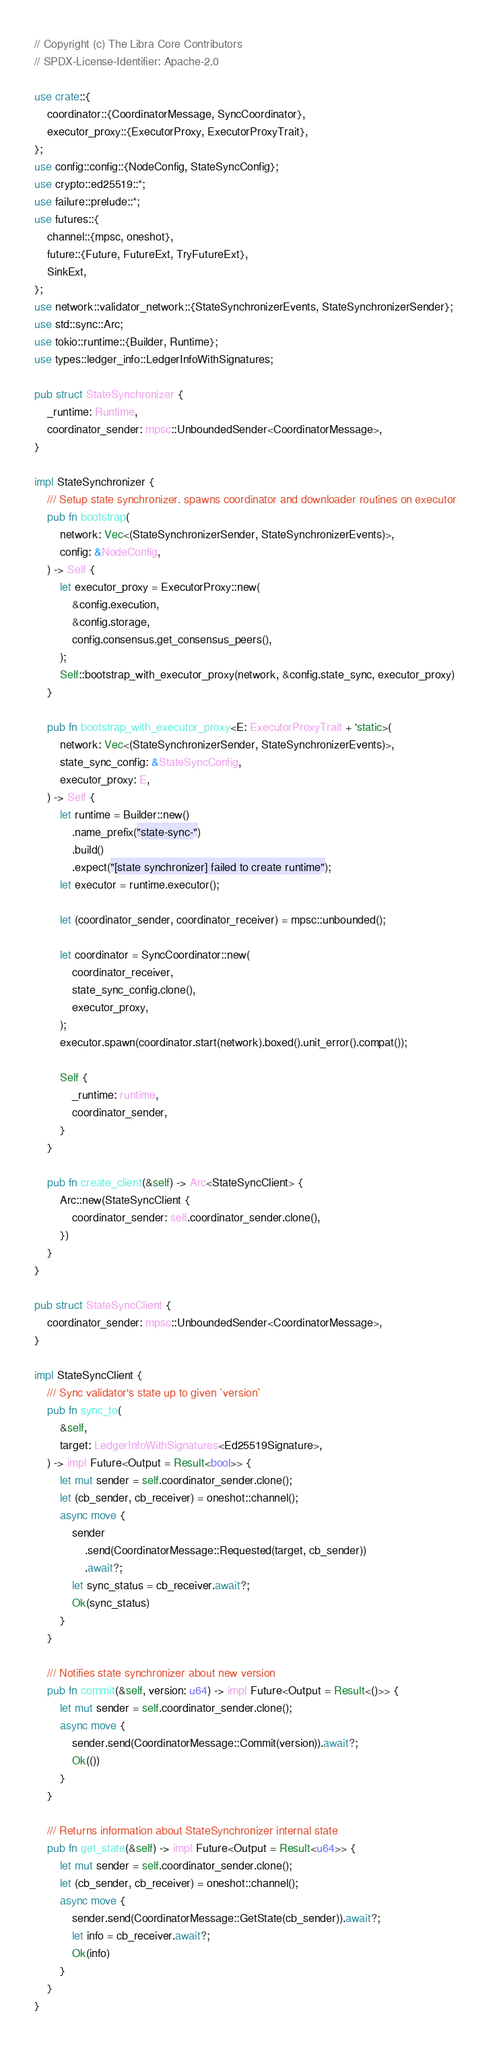Convert code to text. <code><loc_0><loc_0><loc_500><loc_500><_Rust_>// Copyright (c) The Libra Core Contributors
// SPDX-License-Identifier: Apache-2.0

use crate::{
    coordinator::{CoordinatorMessage, SyncCoordinator},
    executor_proxy::{ExecutorProxy, ExecutorProxyTrait},
};
use config::config::{NodeConfig, StateSyncConfig};
use crypto::ed25519::*;
use failure::prelude::*;
use futures::{
    channel::{mpsc, oneshot},
    future::{Future, FutureExt, TryFutureExt},
    SinkExt,
};
use network::validator_network::{StateSynchronizerEvents, StateSynchronizerSender};
use std::sync::Arc;
use tokio::runtime::{Builder, Runtime};
use types::ledger_info::LedgerInfoWithSignatures;

pub struct StateSynchronizer {
    _runtime: Runtime,
    coordinator_sender: mpsc::UnboundedSender<CoordinatorMessage>,
}

impl StateSynchronizer {
    /// Setup state synchronizer. spawns coordinator and downloader routines on executor
    pub fn bootstrap(
        network: Vec<(StateSynchronizerSender, StateSynchronizerEvents)>,
        config: &NodeConfig,
    ) -> Self {
        let executor_proxy = ExecutorProxy::new(
            &config.execution,
            &config.storage,
            config.consensus.get_consensus_peers(),
        );
        Self::bootstrap_with_executor_proxy(network, &config.state_sync, executor_proxy)
    }

    pub fn bootstrap_with_executor_proxy<E: ExecutorProxyTrait + 'static>(
        network: Vec<(StateSynchronizerSender, StateSynchronizerEvents)>,
        state_sync_config: &StateSyncConfig,
        executor_proxy: E,
    ) -> Self {
        let runtime = Builder::new()
            .name_prefix("state-sync-")
            .build()
            .expect("[state synchronizer] failed to create runtime");
        let executor = runtime.executor();

        let (coordinator_sender, coordinator_receiver) = mpsc::unbounded();

        let coordinator = SyncCoordinator::new(
            coordinator_receiver,
            state_sync_config.clone(),
            executor_proxy,
        );
        executor.spawn(coordinator.start(network).boxed().unit_error().compat());

        Self {
            _runtime: runtime,
            coordinator_sender,
        }
    }

    pub fn create_client(&self) -> Arc<StateSyncClient> {
        Arc::new(StateSyncClient {
            coordinator_sender: self.coordinator_sender.clone(),
        })
    }
}

pub struct StateSyncClient {
    coordinator_sender: mpsc::UnboundedSender<CoordinatorMessage>,
}

impl StateSyncClient {
    /// Sync validator's state up to given `version`
    pub fn sync_to(
        &self,
        target: LedgerInfoWithSignatures<Ed25519Signature>,
    ) -> impl Future<Output = Result<bool>> {
        let mut sender = self.coordinator_sender.clone();
        let (cb_sender, cb_receiver) = oneshot::channel();
        async move {
            sender
                .send(CoordinatorMessage::Requested(target, cb_sender))
                .await?;
            let sync_status = cb_receiver.await?;
            Ok(sync_status)
        }
    }

    /// Notifies state synchronizer about new version
    pub fn commit(&self, version: u64) -> impl Future<Output = Result<()>> {
        let mut sender = self.coordinator_sender.clone();
        async move {
            sender.send(CoordinatorMessage::Commit(version)).await?;
            Ok(())
        }
    }

    /// Returns information about StateSynchronizer internal state
    pub fn get_state(&self) -> impl Future<Output = Result<u64>> {
        let mut sender = self.coordinator_sender.clone();
        let (cb_sender, cb_receiver) = oneshot::channel();
        async move {
            sender.send(CoordinatorMessage::GetState(cb_sender)).await?;
            let info = cb_receiver.await?;
            Ok(info)
        }
    }
}
</code> 